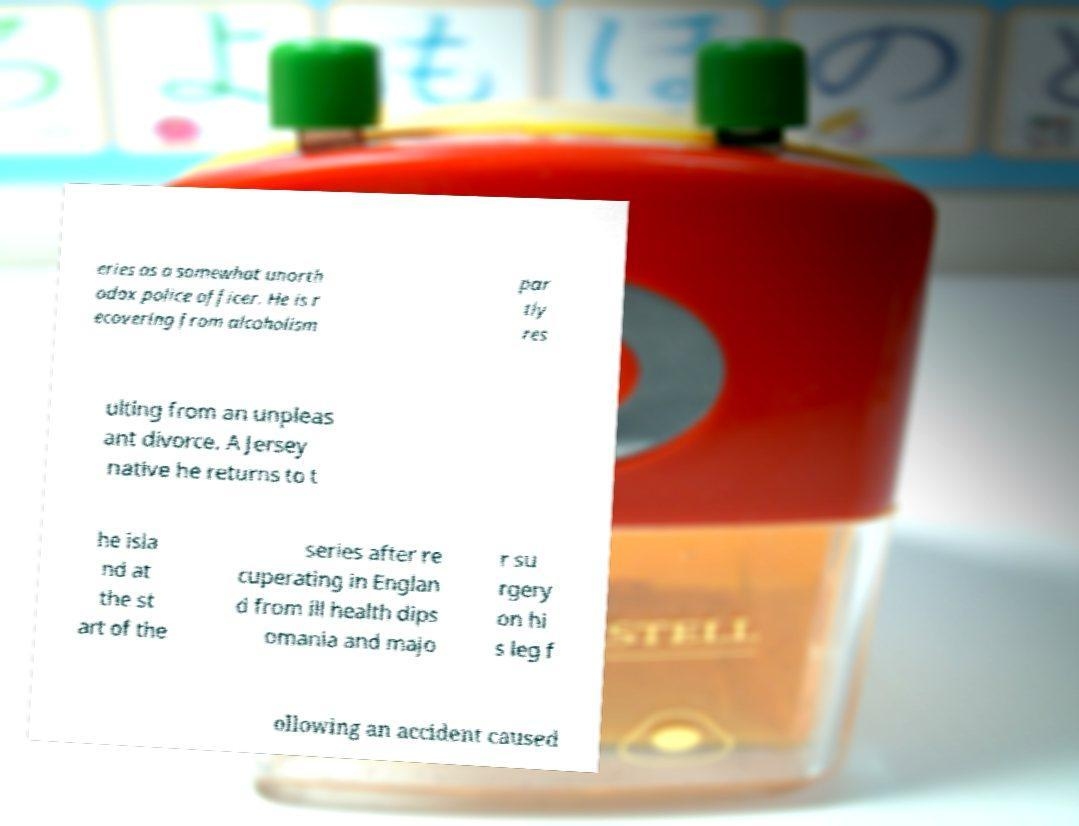Please read and relay the text visible in this image. What does it say? eries as a somewhat unorth odox police officer. He is r ecovering from alcoholism par tly res ulting from an unpleas ant divorce. A Jersey native he returns to t he isla nd at the st art of the series after re cuperating in Englan d from ill health dips omania and majo r su rgery on hi s leg f ollowing an accident caused 